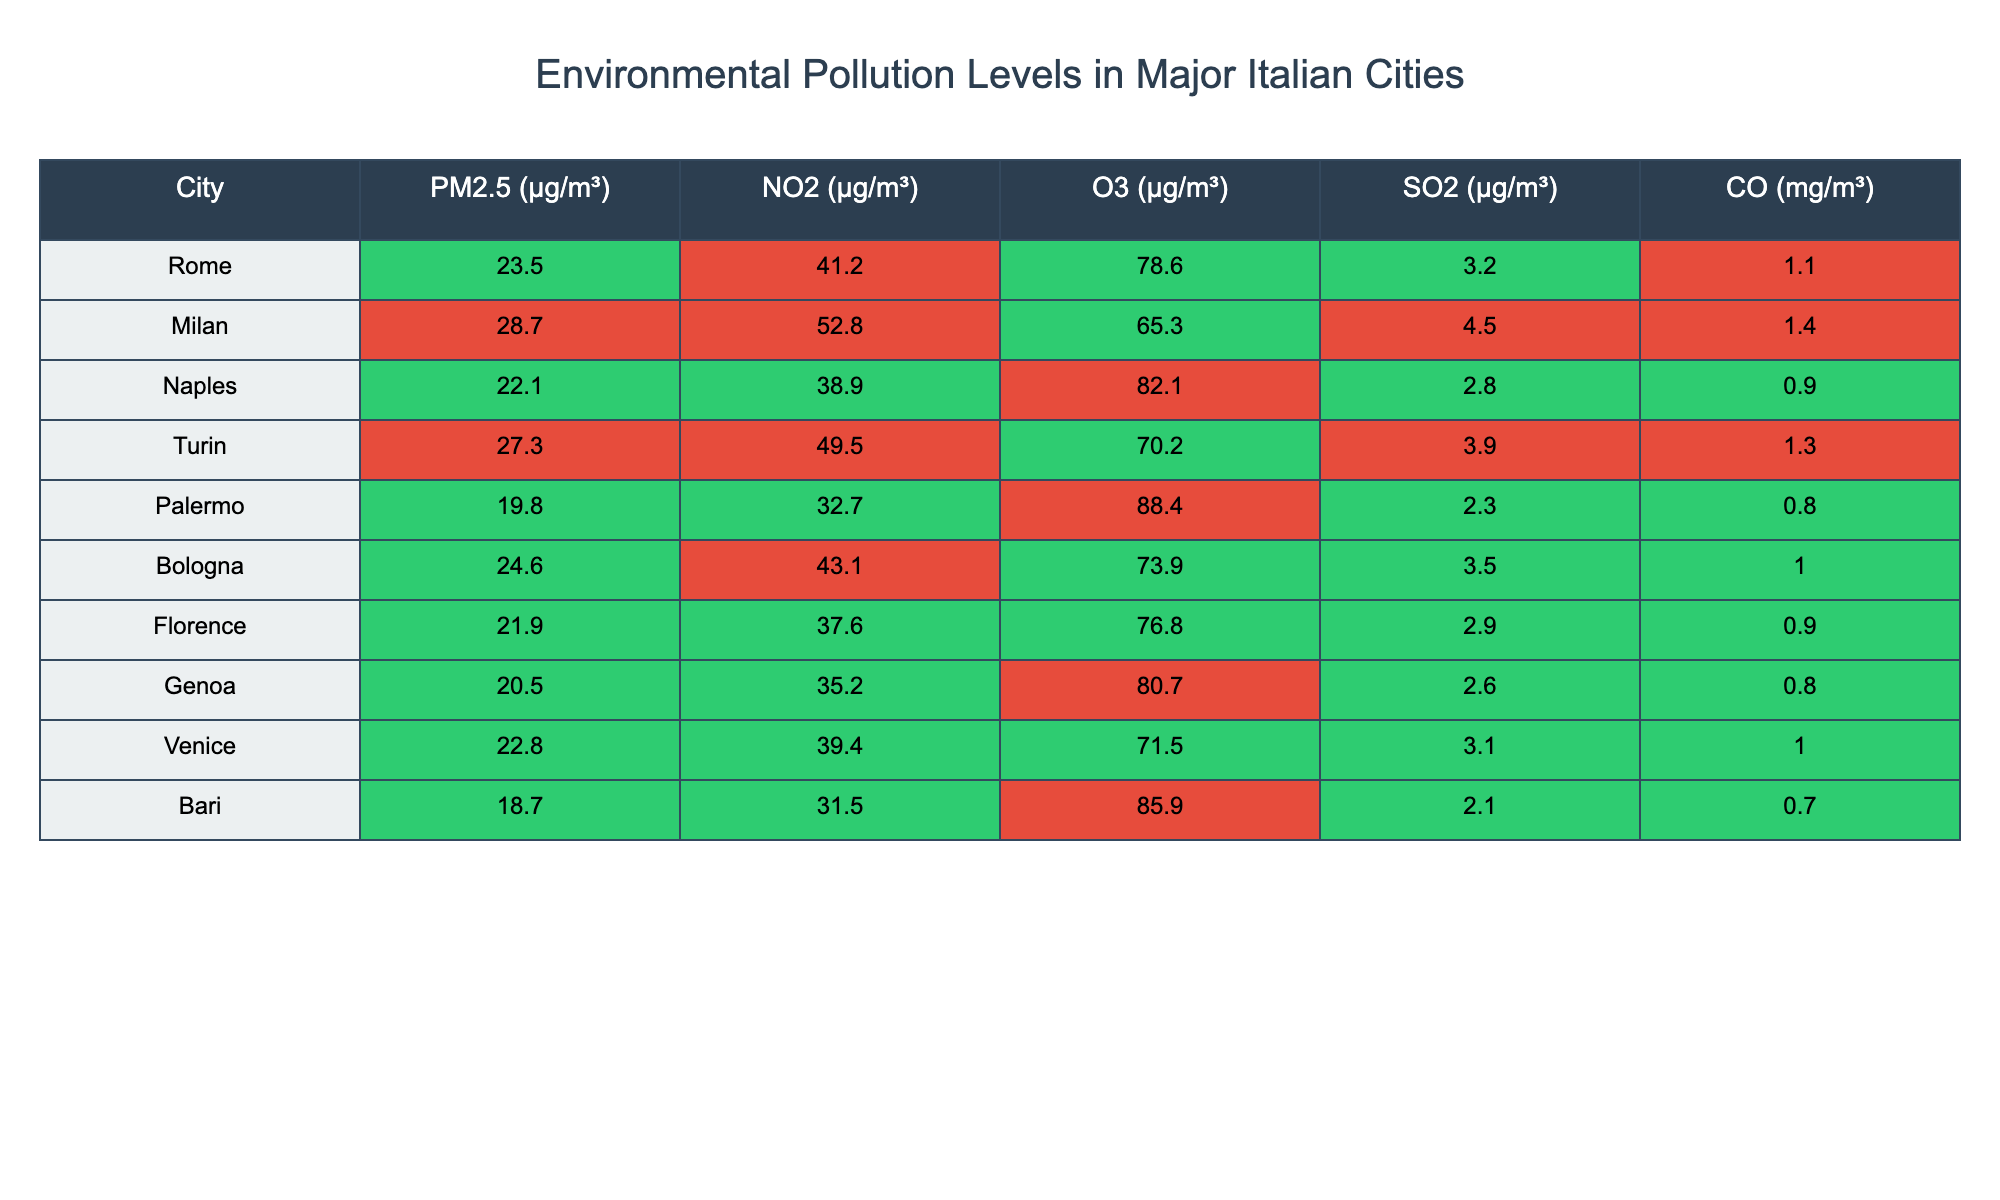What city has the highest PM2.5 level? Looking at the PM2.5 column, the highest value is in Milan at 28.7 µg/m³.
Answer: Milan Which city has the lowest levels of NO2? By examining the NO2 column, Bari has the lowest value at 31.5 µg/m³.
Answer: Bari What is the average SO2 level across all cities? Sum of SO2 values is (3.2 + 4.5 + 2.8 + 3.9 + 2.3 + 3.5 + 2.9 + 2.6 + 3.1 + 2.1) = 27.9 µg/m³. There are 10 cities, so the average is 27.9 / 10 = 2.79 µg/m³.
Answer: 2.79 Is the O3 level in Naples higher than in Turin? The O3 level in Naples is 82.1 µg/m³ and in Turin is 70.2 µg/m³. Since 82.1 is greater than 70.2, the statement is true.
Answer: Yes Which city has both PM2.5 and CO levels below the threshold of 25 µg/m³ and 1 mg/m³ respectively? Reviewing both the PM2.5 and CO columns, only Palermo has PM2.5 at 19.8 µg/m³ and CO at 0.8 mg/m³, both below their respective thresholds.
Answer: Palermo Calculate the difference in NO2 levels between Milan and Florence. The NO2 level in Milan is 52.8 µg/m³ and in Florence is 37.6 µg/m³. The difference is 52.8 - 37.6 = 15.2 µg/m³.
Answer: 15.2 Which city has the highest O3 level and what is that level? Looking through the O3 column, the highest level is in Naples at 82.1 µg/m³.
Answer: Naples, 82.1 Is the pollution level significantly higher in Milan compared to the average PM2.5 of other cities? The average PM2.5 of the other cities (excluding Milan) is (23.5 + 22.1 + 27.3 + 19.8 + 24.6 + 21.9 + 20.5 + 22.8 + 18.7) / 9 = 22.4. Since Milan's PM2.5 is 28.7, it is significantly higher than 22.4.
Answer: Yes How many cities have a NO2 level over 40 µg/m³? Checking the NO2 values, cities above 40 µg/m³ are Milan (52.8), Turin (49.5), and Rome (41.2). There are three cities with NO2 levels above 40.
Answer: 3 What is the CO level for the city with the highest SO2 level? The highest SO2 level is in Milan at 4.5 µg/m³; looking at the CO level for Milan, it is 1.4 mg/m³.
Answer: 1.4 